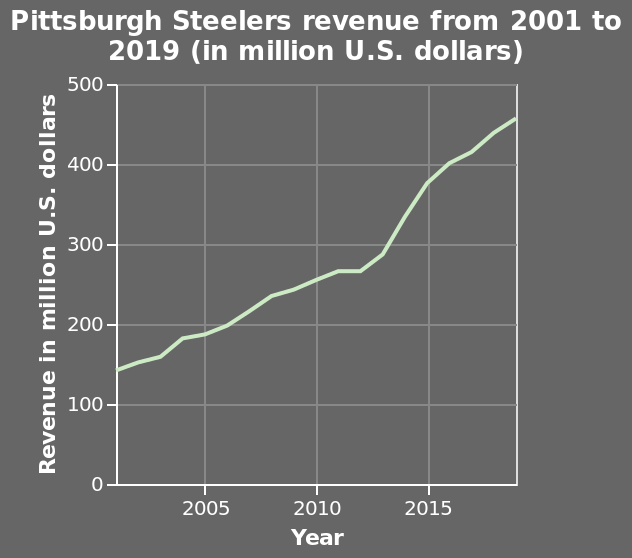<image>
How much revenue was generated in 2019? The revenue generated in 2019 was roughly 450 million US dollars. 